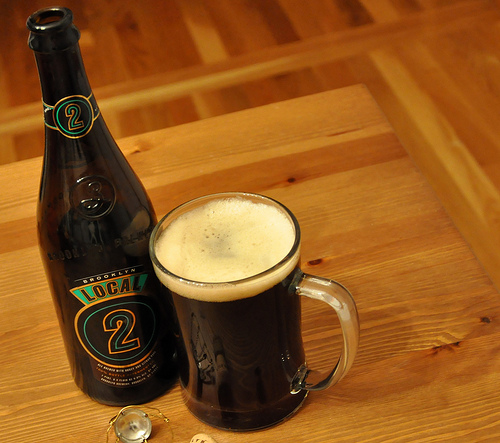<image>
Can you confirm if the cup is on the floor? No. The cup is not positioned on the floor. They may be near each other, but the cup is not supported by or resting on top of the floor. 